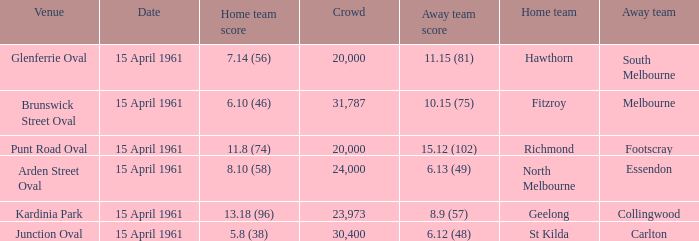Parse the full table. {'header': ['Venue', 'Date', 'Home team score', 'Crowd', 'Away team score', 'Home team', 'Away team'], 'rows': [['Glenferrie Oval', '15 April 1961', '7.14 (56)', '20,000', '11.15 (81)', 'Hawthorn', 'South Melbourne'], ['Brunswick Street Oval', '15 April 1961', '6.10 (46)', '31,787', '10.15 (75)', 'Fitzroy', 'Melbourne'], ['Punt Road Oval', '15 April 1961', '11.8 (74)', '20,000', '15.12 (102)', 'Richmond', 'Footscray'], ['Arden Street Oval', '15 April 1961', '8.10 (58)', '24,000', '6.13 (49)', 'North Melbourne', 'Essendon'], ['Kardinia Park', '15 April 1961', '13.18 (96)', '23,973', '8.9 (57)', 'Geelong', 'Collingwood'], ['Junction Oval', '15 April 1961', '5.8 (38)', '30,400', '6.12 (48)', 'St Kilda', 'Carlton']]} Which venue had a home team score of 6.10 (46)? Brunswick Street Oval. 